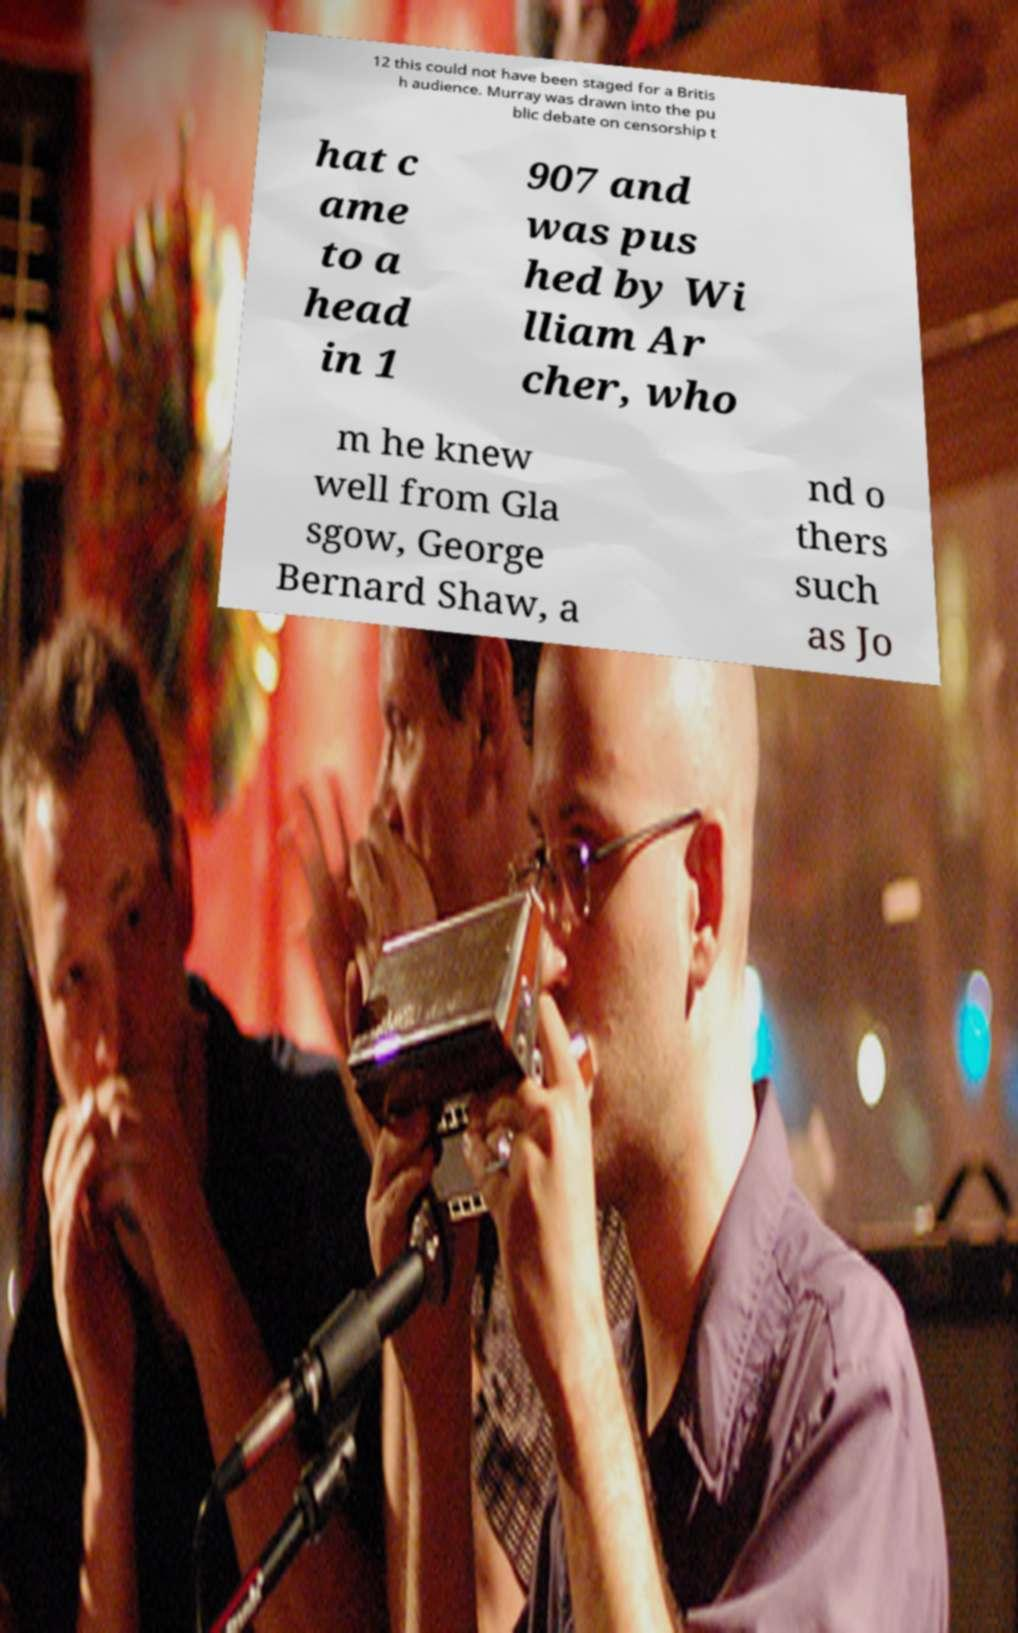There's text embedded in this image that I need extracted. Can you transcribe it verbatim? 12 this could not have been staged for a Britis h audience. Murray was drawn into the pu blic debate on censorship t hat c ame to a head in 1 907 and was pus hed by Wi lliam Ar cher, who m he knew well from Gla sgow, George Bernard Shaw, a nd o thers such as Jo 